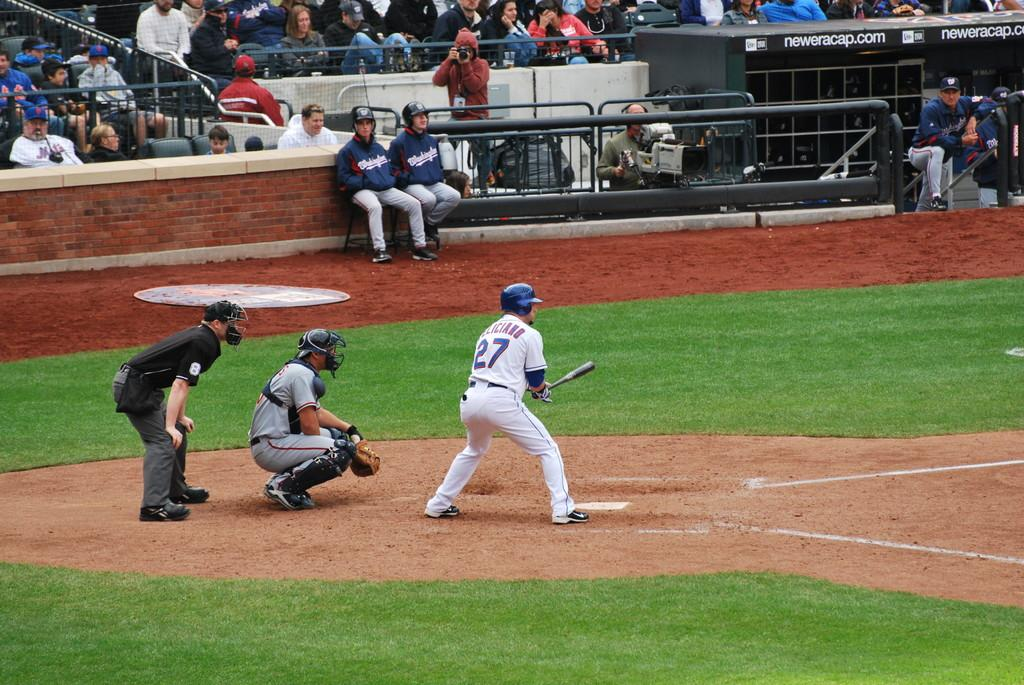<image>
Provide a brief description of the given image. Player number 27 is up to bat hoping to hit a home run. 